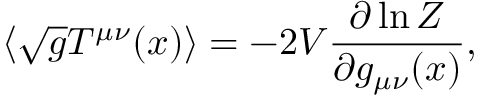Convert formula to latex. <formula><loc_0><loc_0><loc_500><loc_500>\langle \sqrt { g } T ^ { \mu \nu } ( x ) \rangle = - 2 V { \frac { \partial \ln Z } { \partial g _ { \mu \nu } ( x ) } } ,</formula> 